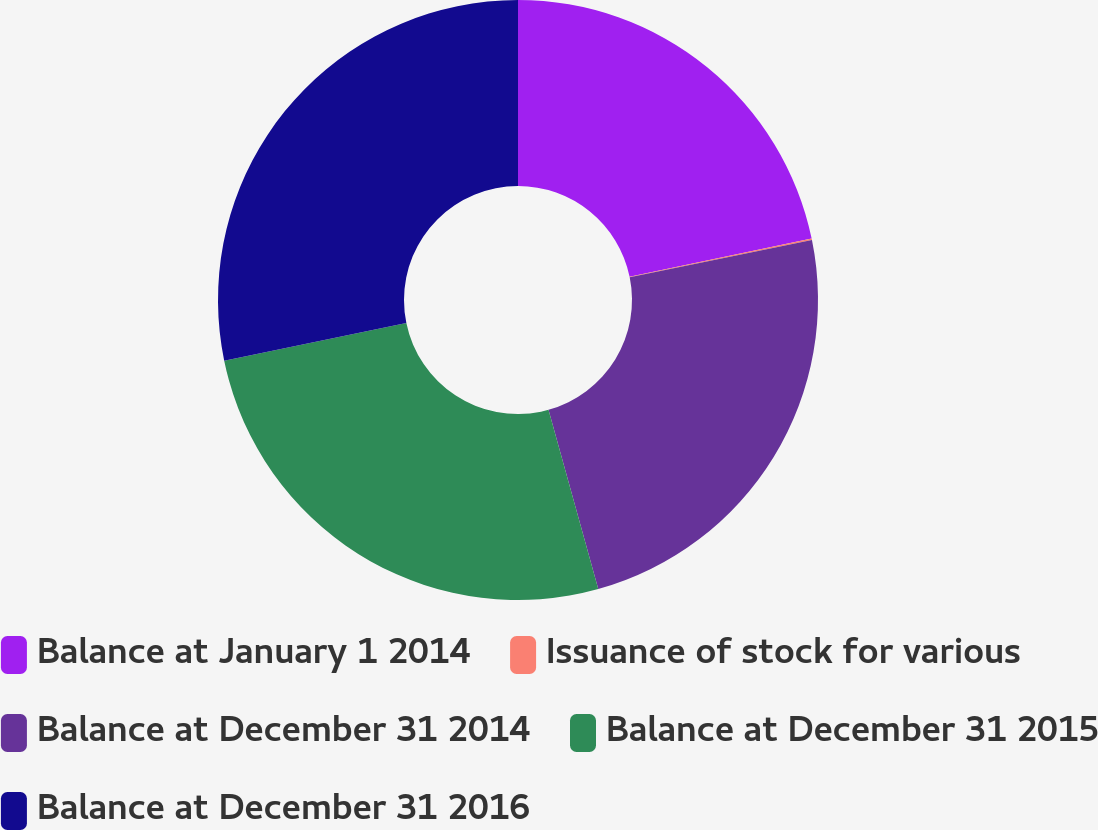<chart> <loc_0><loc_0><loc_500><loc_500><pie_chart><fcel>Balance at January 1 2014<fcel>Issuance of stock for various<fcel>Balance at December 31 2014<fcel>Balance at December 31 2015<fcel>Balance at December 31 2016<nl><fcel>21.72%<fcel>0.08%<fcel>23.89%<fcel>26.07%<fcel>28.24%<nl></chart> 